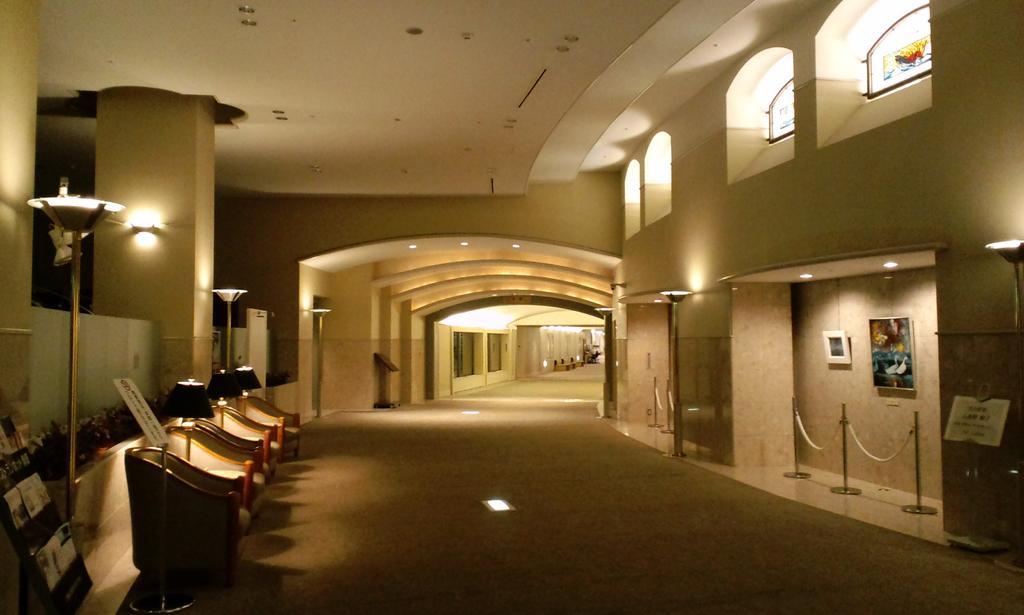Describe this image in one or two sentences. This image consists of sofas along with the lamps. On the left, we can see some plants. On the right, we can see frames on the wall. At the bottom, there is a floor. At the top, there is a roof. On the left, we can see a pillar along with the light. 